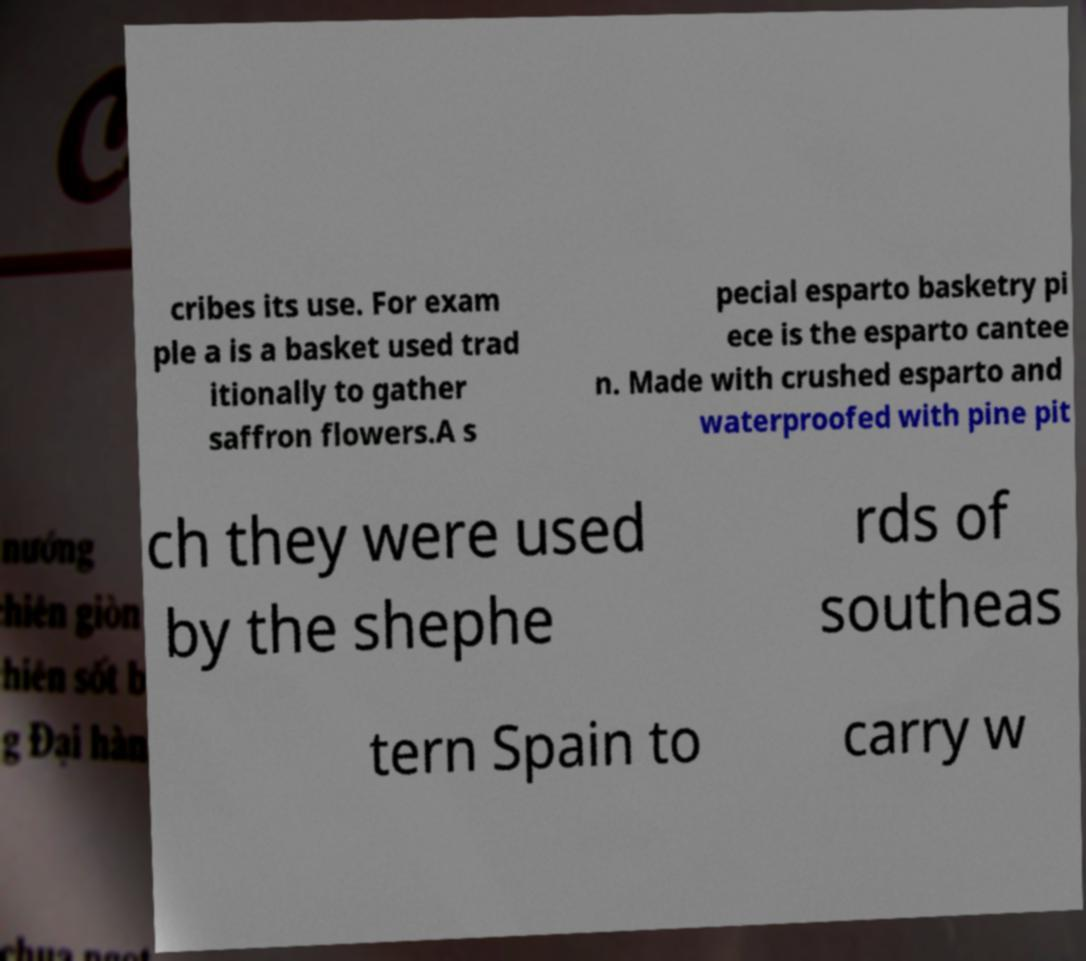There's text embedded in this image that I need extracted. Can you transcribe it verbatim? cribes its use. For exam ple a is a basket used trad itionally to gather saffron flowers.A s pecial esparto basketry pi ece is the esparto cantee n. Made with crushed esparto and waterproofed with pine pit ch they were used by the shephe rds of southeas tern Spain to carry w 